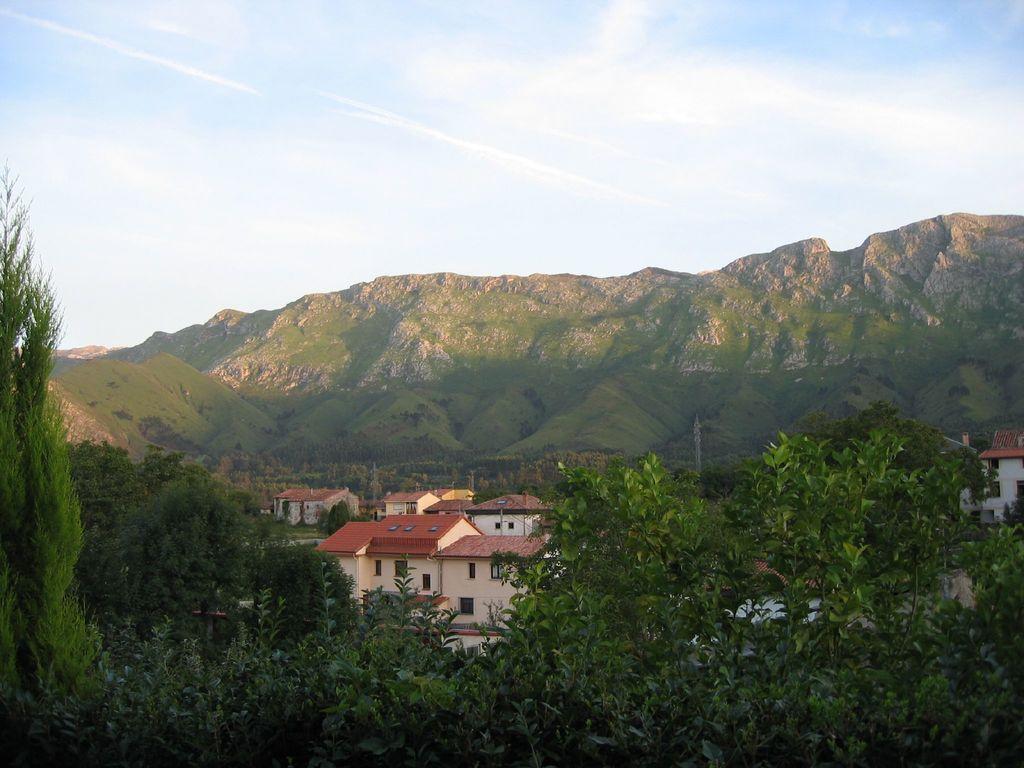Could you give a brief overview of what you see in this image? In front of the image there are trees, behind the trees there are buildings and electric towers, behind them there are mountains. At the top of the image there are clouds in the sky. 